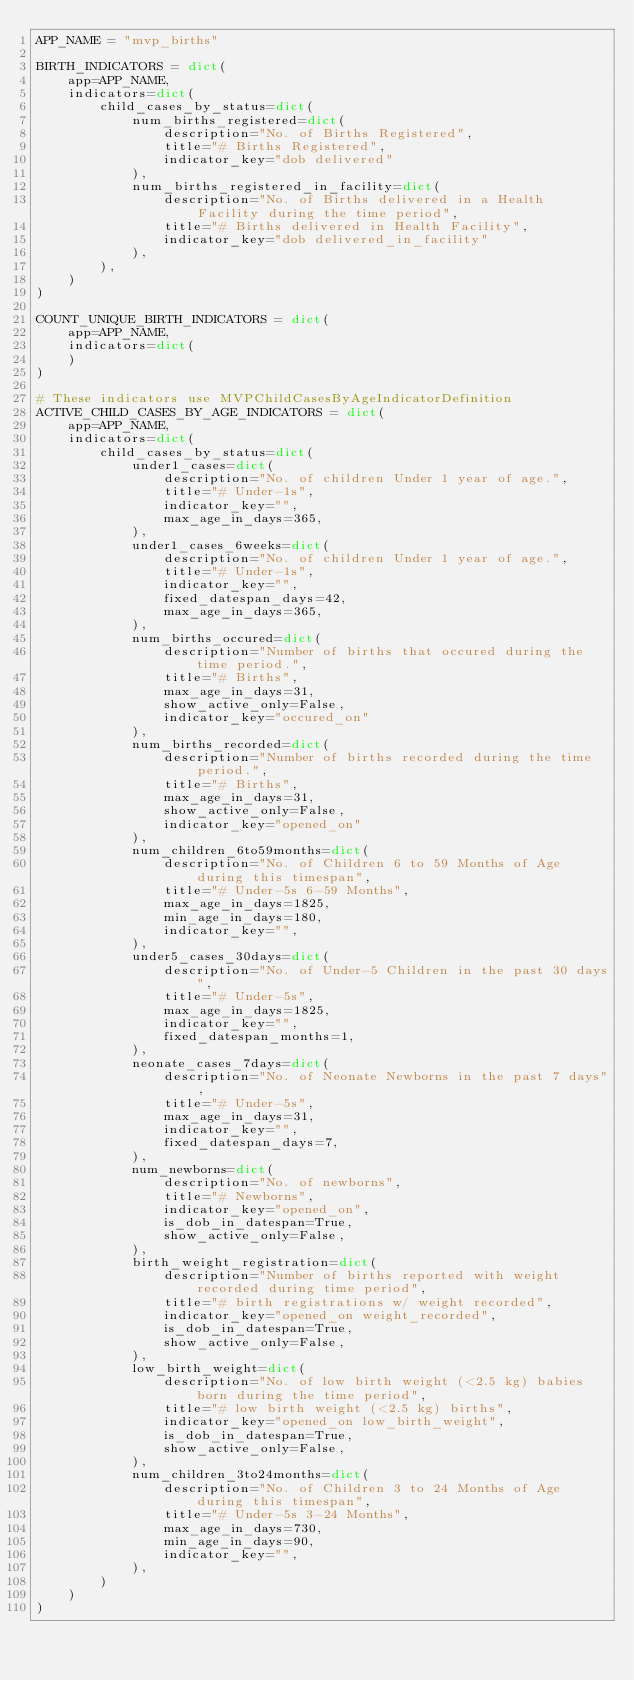<code> <loc_0><loc_0><loc_500><loc_500><_Python_>APP_NAME = "mvp_births"

BIRTH_INDICATORS = dict(
    app=APP_NAME,
    indicators=dict(
        child_cases_by_status=dict(
            num_births_registered=dict(
                description="No. of Births Registered",
                title="# Births Registered",
                indicator_key="dob delivered"
            ),
            num_births_registered_in_facility=dict(
                description="No. of Births delivered in a Health Facility during the time period",
                title="# Births delivered in Health Facility",
                indicator_key="dob delivered_in_facility"
            ),
        ),
    )
)

COUNT_UNIQUE_BIRTH_INDICATORS = dict(
    app=APP_NAME,
    indicators=dict(
    )
)

# These indicators use MVPChildCasesByAgeIndicatorDefinition
ACTIVE_CHILD_CASES_BY_AGE_INDICATORS = dict(
    app=APP_NAME,
    indicators=dict(
        child_cases_by_status=dict(
            under1_cases=dict(
                description="No. of children Under 1 year of age.",
                title="# Under-1s",
                indicator_key="",
                max_age_in_days=365,
            ),
            under1_cases_6weeks=dict(
                description="No. of children Under 1 year of age.",
                title="# Under-1s",
                indicator_key="",
                fixed_datespan_days=42,
                max_age_in_days=365,
            ),
            num_births_occured=dict(
                description="Number of births that occured during the time period.",
                title="# Births",
                max_age_in_days=31,
                show_active_only=False,
                indicator_key="occured_on"
            ),
            num_births_recorded=dict(
                description="Number of births recorded during the time period.",
                title="# Births",
                max_age_in_days=31,
                show_active_only=False,
                indicator_key="opened_on"
            ),
            num_children_6to59months=dict(
                description="No. of Children 6 to 59 Months of Age during this timespan",
                title="# Under-5s 6-59 Months",
                max_age_in_days=1825,
                min_age_in_days=180,
                indicator_key="",
            ),
            under5_cases_30days=dict(
                description="No. of Under-5 Children in the past 30 days",
                title="# Under-5s",
                max_age_in_days=1825,
                indicator_key="",
                fixed_datespan_months=1,
            ),
            neonate_cases_7days=dict(
                description="No. of Neonate Newborns in the past 7 days",
                title="# Under-5s",
                max_age_in_days=31,
                indicator_key="",
                fixed_datespan_days=7,
            ),
            num_newborns=dict(
                description="No. of newborns",
                title="# Newborns",
                indicator_key="opened_on",
                is_dob_in_datespan=True,
                show_active_only=False,
            ),
            birth_weight_registration=dict(
                description="Number of births reported with weight recorded during time period",
                title="# birth registrations w/ weight recorded",
                indicator_key="opened_on weight_recorded",
                is_dob_in_datespan=True,
                show_active_only=False,
            ),
            low_birth_weight=dict(
                description="No. of low birth weight (<2.5 kg) babies born during the time period",
                title="# low birth weight (<2.5 kg) births",
                indicator_key="opened_on low_birth_weight",
                is_dob_in_datespan=True,
                show_active_only=False,
            ),
            num_children_3to24months=dict(
                description="No. of Children 3 to 24 Months of Age during this timespan",
                title="# Under-5s 3-24 Months",
                max_age_in_days=730,
                min_age_in_days=90,
                indicator_key="",
            ),
        )
    )
)
</code> 